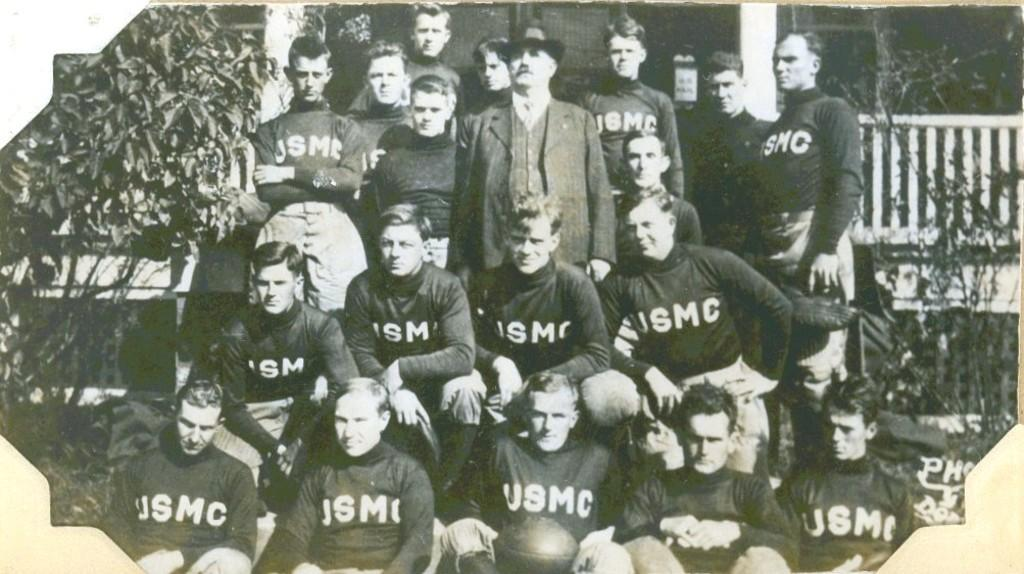What is the color scheme of the image? The image is black and white. Who or what can be seen in the image? There are people in the image. What type of natural elements are present in the image? There are trees in the image. What type of structure is visible in the image? There is a grille in the image. What can be seen on the clothing of some people in the image? There is writing on the t-shirts of some people. Can you tell me how many chess pieces are on the plough in the image? There is no plough or chess pieces present in the image. What type of pleasure can be seen being derived from the activity in the image? The image does not depict any specific activity or pleasure; it only shows people, trees, a grille, and writing on t-shirts. 